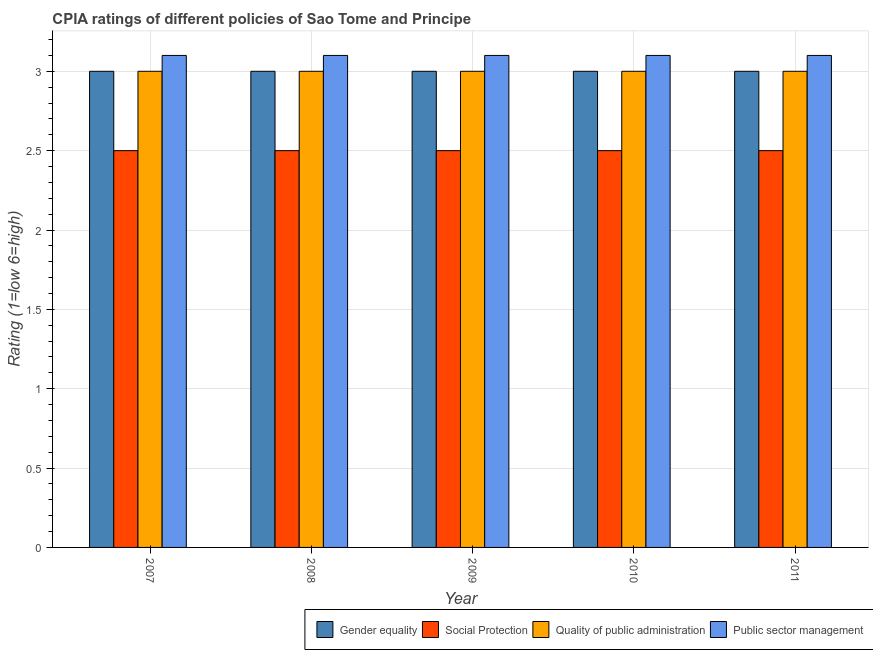How many groups of bars are there?
Make the answer very short. 5. Are the number of bars per tick equal to the number of legend labels?
Offer a terse response. Yes. Are the number of bars on each tick of the X-axis equal?
Provide a short and direct response. Yes. How many bars are there on the 4th tick from the left?
Offer a terse response. 4. In how many cases, is the number of bars for a given year not equal to the number of legend labels?
Your answer should be very brief. 0. Across all years, what is the maximum cpia rating of social protection?
Your answer should be very brief. 2.5. Across all years, what is the minimum cpia rating of gender equality?
Ensure brevity in your answer.  3. In which year was the cpia rating of gender equality minimum?
Provide a short and direct response. 2007. What is the total cpia rating of gender equality in the graph?
Make the answer very short. 15. What is the average cpia rating of gender equality per year?
Make the answer very short. 3. What is the ratio of the cpia rating of social protection in 2007 to that in 2008?
Ensure brevity in your answer.  1. Is the cpia rating of public sector management in 2007 less than that in 2011?
Make the answer very short. No. In how many years, is the cpia rating of public sector management greater than the average cpia rating of public sector management taken over all years?
Your answer should be very brief. 0. What does the 1st bar from the left in 2008 represents?
Provide a succinct answer. Gender equality. What does the 2nd bar from the right in 2011 represents?
Ensure brevity in your answer.  Quality of public administration. Is it the case that in every year, the sum of the cpia rating of gender equality and cpia rating of social protection is greater than the cpia rating of quality of public administration?
Keep it short and to the point. Yes. How many bars are there?
Your answer should be compact. 20. Are all the bars in the graph horizontal?
Offer a very short reply. No. Does the graph contain any zero values?
Offer a terse response. No. Where does the legend appear in the graph?
Provide a succinct answer. Bottom right. How are the legend labels stacked?
Your answer should be compact. Horizontal. What is the title of the graph?
Make the answer very short. CPIA ratings of different policies of Sao Tome and Principe. Does "Iceland" appear as one of the legend labels in the graph?
Provide a short and direct response. No. What is the label or title of the X-axis?
Provide a short and direct response. Year. What is the label or title of the Y-axis?
Your answer should be compact. Rating (1=low 6=high). What is the Rating (1=low 6=high) of Social Protection in 2007?
Your answer should be compact. 2.5. What is the Rating (1=low 6=high) of Public sector management in 2007?
Give a very brief answer. 3.1. What is the Rating (1=low 6=high) of Quality of public administration in 2008?
Provide a succinct answer. 3. What is the Rating (1=low 6=high) of Public sector management in 2008?
Provide a short and direct response. 3.1. What is the Rating (1=low 6=high) in Gender equality in 2010?
Give a very brief answer. 3. What is the Rating (1=low 6=high) in Gender equality in 2011?
Your answer should be very brief. 3. What is the Rating (1=low 6=high) of Social Protection in 2011?
Your answer should be very brief. 2.5. What is the Rating (1=low 6=high) in Quality of public administration in 2011?
Make the answer very short. 3. Across all years, what is the maximum Rating (1=low 6=high) in Social Protection?
Ensure brevity in your answer.  2.5. Across all years, what is the minimum Rating (1=low 6=high) of Gender equality?
Provide a succinct answer. 3. Across all years, what is the minimum Rating (1=low 6=high) of Quality of public administration?
Offer a terse response. 3. Across all years, what is the minimum Rating (1=low 6=high) in Public sector management?
Provide a short and direct response. 3.1. What is the total Rating (1=low 6=high) of Gender equality in the graph?
Your answer should be compact. 15. What is the difference between the Rating (1=low 6=high) in Quality of public administration in 2007 and that in 2008?
Make the answer very short. 0. What is the difference between the Rating (1=low 6=high) of Public sector management in 2007 and that in 2009?
Make the answer very short. 0. What is the difference between the Rating (1=low 6=high) of Social Protection in 2007 and that in 2010?
Provide a succinct answer. 0. What is the difference between the Rating (1=low 6=high) of Social Protection in 2007 and that in 2011?
Ensure brevity in your answer.  0. What is the difference between the Rating (1=low 6=high) in Quality of public administration in 2007 and that in 2011?
Provide a succinct answer. 0. What is the difference between the Rating (1=low 6=high) of Public sector management in 2007 and that in 2011?
Offer a terse response. 0. What is the difference between the Rating (1=low 6=high) of Public sector management in 2008 and that in 2009?
Provide a succinct answer. 0. What is the difference between the Rating (1=low 6=high) in Social Protection in 2008 and that in 2010?
Give a very brief answer. 0. What is the difference between the Rating (1=low 6=high) in Quality of public administration in 2008 and that in 2010?
Keep it short and to the point. 0. What is the difference between the Rating (1=low 6=high) in Gender equality in 2008 and that in 2011?
Offer a very short reply. 0. What is the difference between the Rating (1=low 6=high) in Quality of public administration in 2008 and that in 2011?
Your response must be concise. 0. What is the difference between the Rating (1=low 6=high) in Social Protection in 2009 and that in 2010?
Ensure brevity in your answer.  0. What is the difference between the Rating (1=low 6=high) in Quality of public administration in 2009 and that in 2010?
Make the answer very short. 0. What is the difference between the Rating (1=low 6=high) of Public sector management in 2009 and that in 2010?
Provide a short and direct response. 0. What is the difference between the Rating (1=low 6=high) of Public sector management in 2009 and that in 2011?
Make the answer very short. 0. What is the difference between the Rating (1=low 6=high) in Gender equality in 2010 and that in 2011?
Your answer should be compact. 0. What is the difference between the Rating (1=low 6=high) of Quality of public administration in 2010 and that in 2011?
Ensure brevity in your answer.  0. What is the difference between the Rating (1=low 6=high) in Public sector management in 2010 and that in 2011?
Provide a short and direct response. 0. What is the difference between the Rating (1=low 6=high) of Social Protection in 2007 and the Rating (1=low 6=high) of Quality of public administration in 2008?
Your response must be concise. -0.5. What is the difference between the Rating (1=low 6=high) of Gender equality in 2007 and the Rating (1=low 6=high) of Social Protection in 2009?
Offer a very short reply. 0.5. What is the difference between the Rating (1=low 6=high) of Gender equality in 2007 and the Rating (1=low 6=high) of Quality of public administration in 2009?
Offer a terse response. 0. What is the difference between the Rating (1=low 6=high) in Social Protection in 2007 and the Rating (1=low 6=high) in Quality of public administration in 2009?
Keep it short and to the point. -0.5. What is the difference between the Rating (1=low 6=high) of Social Protection in 2007 and the Rating (1=low 6=high) of Public sector management in 2009?
Make the answer very short. -0.6. What is the difference between the Rating (1=low 6=high) of Quality of public administration in 2007 and the Rating (1=low 6=high) of Public sector management in 2009?
Offer a terse response. -0.1. What is the difference between the Rating (1=low 6=high) of Gender equality in 2007 and the Rating (1=low 6=high) of Quality of public administration in 2010?
Provide a short and direct response. 0. What is the difference between the Rating (1=low 6=high) in Gender equality in 2007 and the Rating (1=low 6=high) in Public sector management in 2010?
Provide a succinct answer. -0.1. What is the difference between the Rating (1=low 6=high) of Social Protection in 2007 and the Rating (1=low 6=high) of Quality of public administration in 2010?
Make the answer very short. -0.5. What is the difference between the Rating (1=low 6=high) in Quality of public administration in 2007 and the Rating (1=low 6=high) in Public sector management in 2010?
Your response must be concise. -0.1. What is the difference between the Rating (1=low 6=high) of Gender equality in 2007 and the Rating (1=low 6=high) of Social Protection in 2011?
Give a very brief answer. 0.5. What is the difference between the Rating (1=low 6=high) in Social Protection in 2007 and the Rating (1=low 6=high) in Public sector management in 2011?
Your response must be concise. -0.6. What is the difference between the Rating (1=low 6=high) of Gender equality in 2008 and the Rating (1=low 6=high) of Social Protection in 2009?
Offer a very short reply. 0.5. What is the difference between the Rating (1=low 6=high) of Gender equality in 2008 and the Rating (1=low 6=high) of Public sector management in 2009?
Make the answer very short. -0.1. What is the difference between the Rating (1=low 6=high) of Social Protection in 2008 and the Rating (1=low 6=high) of Quality of public administration in 2009?
Ensure brevity in your answer.  -0.5. What is the difference between the Rating (1=low 6=high) in Quality of public administration in 2008 and the Rating (1=low 6=high) in Public sector management in 2009?
Your answer should be compact. -0.1. What is the difference between the Rating (1=low 6=high) in Gender equality in 2008 and the Rating (1=low 6=high) in Quality of public administration in 2010?
Your response must be concise. 0. What is the difference between the Rating (1=low 6=high) of Social Protection in 2008 and the Rating (1=low 6=high) of Quality of public administration in 2010?
Your answer should be very brief. -0.5. What is the difference between the Rating (1=low 6=high) in Quality of public administration in 2008 and the Rating (1=low 6=high) in Public sector management in 2010?
Your response must be concise. -0.1. What is the difference between the Rating (1=low 6=high) in Gender equality in 2008 and the Rating (1=low 6=high) in Social Protection in 2011?
Provide a short and direct response. 0.5. What is the difference between the Rating (1=low 6=high) in Social Protection in 2008 and the Rating (1=low 6=high) in Public sector management in 2011?
Offer a terse response. -0.6. What is the difference between the Rating (1=low 6=high) of Quality of public administration in 2008 and the Rating (1=low 6=high) of Public sector management in 2011?
Provide a short and direct response. -0.1. What is the difference between the Rating (1=low 6=high) in Gender equality in 2009 and the Rating (1=low 6=high) in Social Protection in 2010?
Your response must be concise. 0.5. What is the difference between the Rating (1=low 6=high) of Gender equality in 2009 and the Rating (1=low 6=high) of Quality of public administration in 2010?
Provide a succinct answer. 0. What is the difference between the Rating (1=low 6=high) in Gender equality in 2009 and the Rating (1=low 6=high) in Public sector management in 2010?
Provide a short and direct response. -0.1. What is the difference between the Rating (1=low 6=high) of Social Protection in 2009 and the Rating (1=low 6=high) of Public sector management in 2010?
Keep it short and to the point. -0.6. What is the difference between the Rating (1=low 6=high) in Quality of public administration in 2009 and the Rating (1=low 6=high) in Public sector management in 2010?
Keep it short and to the point. -0.1. What is the difference between the Rating (1=low 6=high) in Gender equality in 2009 and the Rating (1=low 6=high) in Quality of public administration in 2011?
Make the answer very short. 0. What is the difference between the Rating (1=low 6=high) in Gender equality in 2009 and the Rating (1=low 6=high) in Public sector management in 2011?
Offer a terse response. -0.1. What is the difference between the Rating (1=low 6=high) of Social Protection in 2009 and the Rating (1=low 6=high) of Public sector management in 2011?
Ensure brevity in your answer.  -0.6. What is the difference between the Rating (1=low 6=high) in Gender equality in 2010 and the Rating (1=low 6=high) in Social Protection in 2011?
Keep it short and to the point. 0.5. What is the average Rating (1=low 6=high) in Gender equality per year?
Offer a very short reply. 3. What is the average Rating (1=low 6=high) in Social Protection per year?
Provide a succinct answer. 2.5. What is the average Rating (1=low 6=high) in Public sector management per year?
Your answer should be very brief. 3.1. In the year 2007, what is the difference between the Rating (1=low 6=high) of Gender equality and Rating (1=low 6=high) of Public sector management?
Your response must be concise. -0.1. In the year 2007, what is the difference between the Rating (1=low 6=high) in Social Protection and Rating (1=low 6=high) in Public sector management?
Ensure brevity in your answer.  -0.6. In the year 2007, what is the difference between the Rating (1=low 6=high) in Quality of public administration and Rating (1=low 6=high) in Public sector management?
Make the answer very short. -0.1. In the year 2008, what is the difference between the Rating (1=low 6=high) of Social Protection and Rating (1=low 6=high) of Quality of public administration?
Your answer should be very brief. -0.5. In the year 2008, what is the difference between the Rating (1=low 6=high) of Social Protection and Rating (1=low 6=high) of Public sector management?
Ensure brevity in your answer.  -0.6. In the year 2008, what is the difference between the Rating (1=low 6=high) of Quality of public administration and Rating (1=low 6=high) of Public sector management?
Give a very brief answer. -0.1. In the year 2009, what is the difference between the Rating (1=low 6=high) of Gender equality and Rating (1=low 6=high) of Quality of public administration?
Keep it short and to the point. 0. In the year 2009, what is the difference between the Rating (1=low 6=high) of Social Protection and Rating (1=low 6=high) of Quality of public administration?
Give a very brief answer. -0.5. In the year 2009, what is the difference between the Rating (1=low 6=high) of Quality of public administration and Rating (1=low 6=high) of Public sector management?
Offer a very short reply. -0.1. In the year 2010, what is the difference between the Rating (1=low 6=high) of Gender equality and Rating (1=low 6=high) of Social Protection?
Provide a succinct answer. 0.5. In the year 2010, what is the difference between the Rating (1=low 6=high) in Social Protection and Rating (1=low 6=high) in Public sector management?
Provide a short and direct response. -0.6. In the year 2010, what is the difference between the Rating (1=low 6=high) in Quality of public administration and Rating (1=low 6=high) in Public sector management?
Make the answer very short. -0.1. In the year 2011, what is the difference between the Rating (1=low 6=high) of Social Protection and Rating (1=low 6=high) of Quality of public administration?
Give a very brief answer. -0.5. In the year 2011, what is the difference between the Rating (1=low 6=high) in Social Protection and Rating (1=low 6=high) in Public sector management?
Keep it short and to the point. -0.6. What is the ratio of the Rating (1=low 6=high) in Social Protection in 2007 to that in 2008?
Your response must be concise. 1. What is the ratio of the Rating (1=low 6=high) in Quality of public administration in 2007 to that in 2008?
Provide a succinct answer. 1. What is the ratio of the Rating (1=low 6=high) in Public sector management in 2007 to that in 2008?
Ensure brevity in your answer.  1. What is the ratio of the Rating (1=low 6=high) of Social Protection in 2007 to that in 2009?
Give a very brief answer. 1. What is the ratio of the Rating (1=low 6=high) of Quality of public administration in 2007 to that in 2009?
Ensure brevity in your answer.  1. What is the ratio of the Rating (1=low 6=high) in Public sector management in 2007 to that in 2009?
Provide a succinct answer. 1. What is the ratio of the Rating (1=low 6=high) in Public sector management in 2007 to that in 2010?
Give a very brief answer. 1. What is the ratio of the Rating (1=low 6=high) of Gender equality in 2007 to that in 2011?
Your response must be concise. 1. What is the ratio of the Rating (1=low 6=high) of Public sector management in 2007 to that in 2011?
Give a very brief answer. 1. What is the ratio of the Rating (1=low 6=high) of Social Protection in 2008 to that in 2009?
Your response must be concise. 1. What is the ratio of the Rating (1=low 6=high) of Gender equality in 2008 to that in 2010?
Keep it short and to the point. 1. What is the ratio of the Rating (1=low 6=high) in Social Protection in 2008 to that in 2010?
Make the answer very short. 1. What is the ratio of the Rating (1=low 6=high) of Public sector management in 2008 to that in 2010?
Provide a succinct answer. 1. What is the ratio of the Rating (1=low 6=high) in Gender equality in 2008 to that in 2011?
Offer a terse response. 1. What is the ratio of the Rating (1=low 6=high) in Social Protection in 2009 to that in 2010?
Your answer should be compact. 1. What is the ratio of the Rating (1=low 6=high) of Quality of public administration in 2009 to that in 2010?
Provide a succinct answer. 1. What is the ratio of the Rating (1=low 6=high) of Gender equality in 2009 to that in 2011?
Your response must be concise. 1. What is the ratio of the Rating (1=low 6=high) in Social Protection in 2009 to that in 2011?
Offer a terse response. 1. What is the ratio of the Rating (1=low 6=high) in Social Protection in 2010 to that in 2011?
Keep it short and to the point. 1. What is the ratio of the Rating (1=low 6=high) in Quality of public administration in 2010 to that in 2011?
Your answer should be compact. 1. What is the ratio of the Rating (1=low 6=high) of Public sector management in 2010 to that in 2011?
Offer a terse response. 1. What is the difference between the highest and the second highest Rating (1=low 6=high) of Gender equality?
Provide a short and direct response. 0. What is the difference between the highest and the second highest Rating (1=low 6=high) in Quality of public administration?
Ensure brevity in your answer.  0. What is the difference between the highest and the lowest Rating (1=low 6=high) in Public sector management?
Your answer should be compact. 0. 